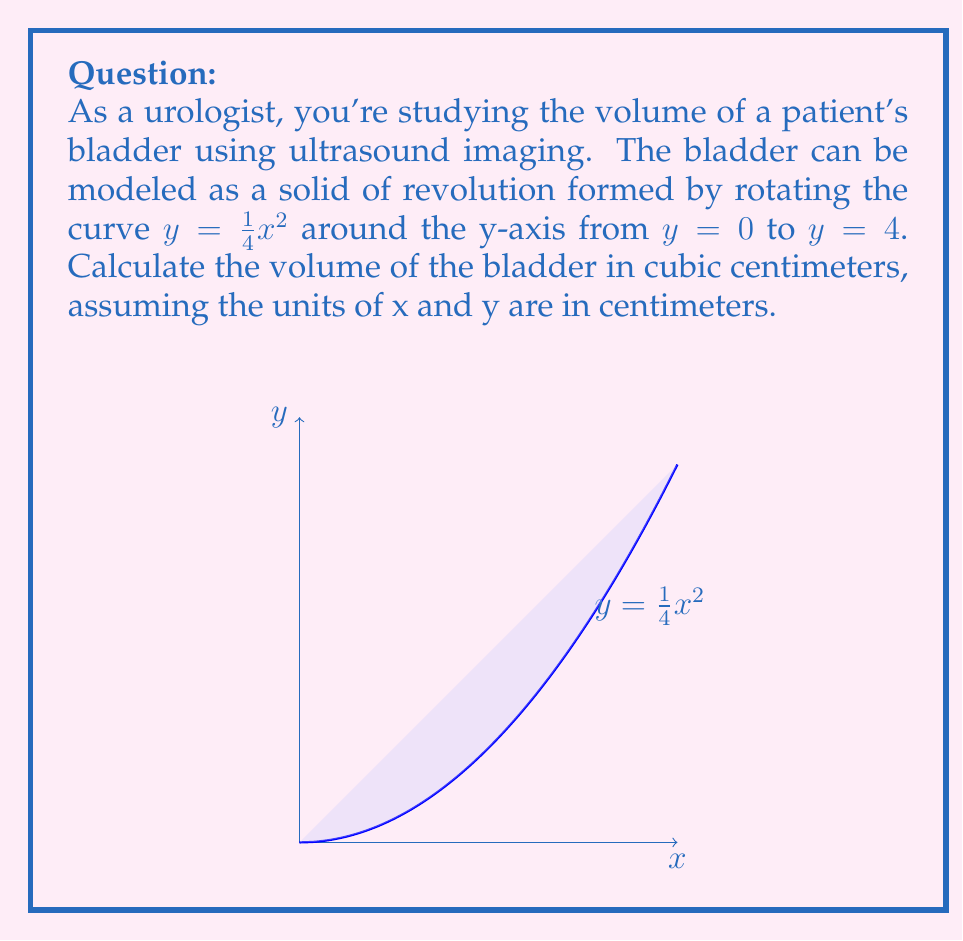Give your solution to this math problem. Let's approach this step-by-step using the washer method for volumes of revolution:

1) The volume is given by the integral:
   $$V = \pi \int_0^4 R(y)^2 dy$$
   where $R(y)$ is the radius of each circular cross-section.

2) We need to express x in terms of y:
   $$y = \frac{1}{4}x^2$$
   $$x^2 = 4y$$
   $$x = 2\sqrt{y}$$

3) Therefore, $R(y) = 2\sqrt{y}$

4) Substituting into our volume formula:
   $$V = \pi \int_0^4 (2\sqrt{y})^2 dy$$
   $$V = 4\pi \int_0^4 y dy$$

5) Evaluating the integral:
   $$V = 4\pi \left[\frac{1}{2}y^2\right]_0^4$$
   $$V = 4\pi \left(\frac{1}{2}(4^2) - \frac{1}{2}(0^2)\right)$$
   $$V = 4\pi \left(8 - 0\right)$$
   $$V = 32\pi$$

6) Since π ≈ 3.14159, we can approximate:
   $$V ≈ 32 * 3.14159 ≈ 100.53 \text{ cm}^3$$
Answer: $100.53 \text{ cm}^3$ 